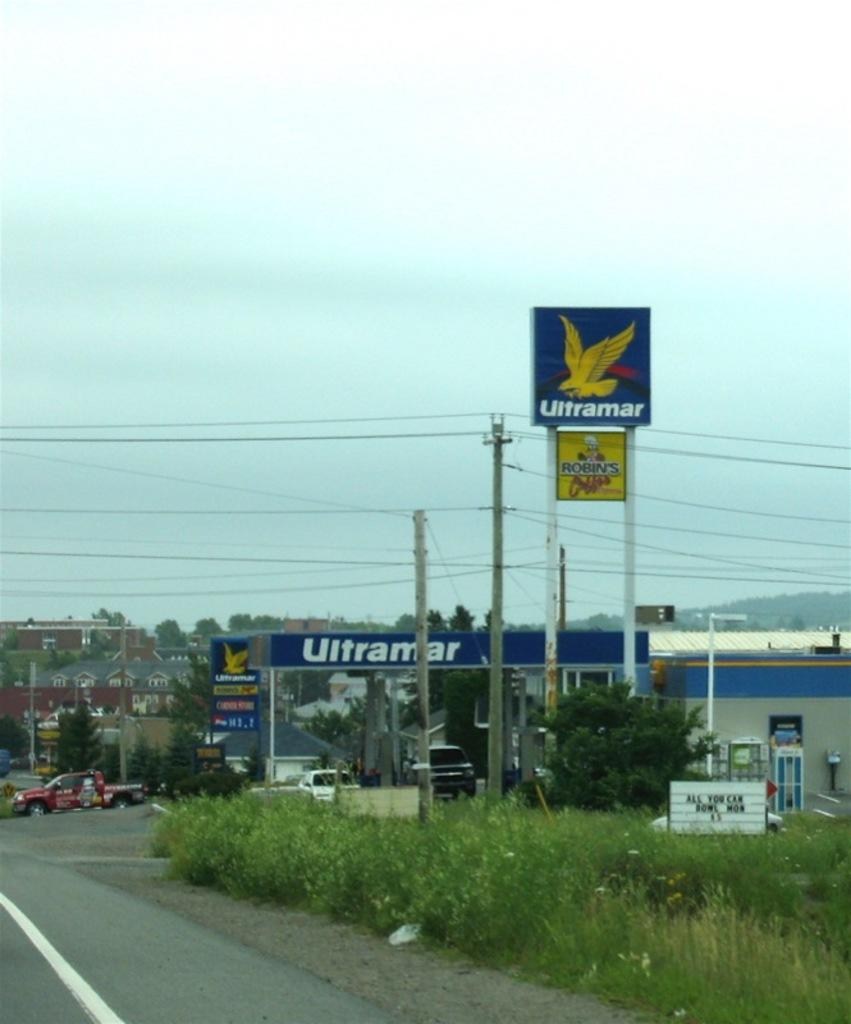What type of vegetation can be seen in the image? There is grass and plants visible in the image. What structures are present in the image? There are boards on poles and poles with wires in the image. What can be seen in the background of the image? There are boards, buildings, trees, and the sky visible in the background of the image. What type of drug is being sold by the bird in the image? There is no bird present in the image, and therefore no drug sales can be observed. 